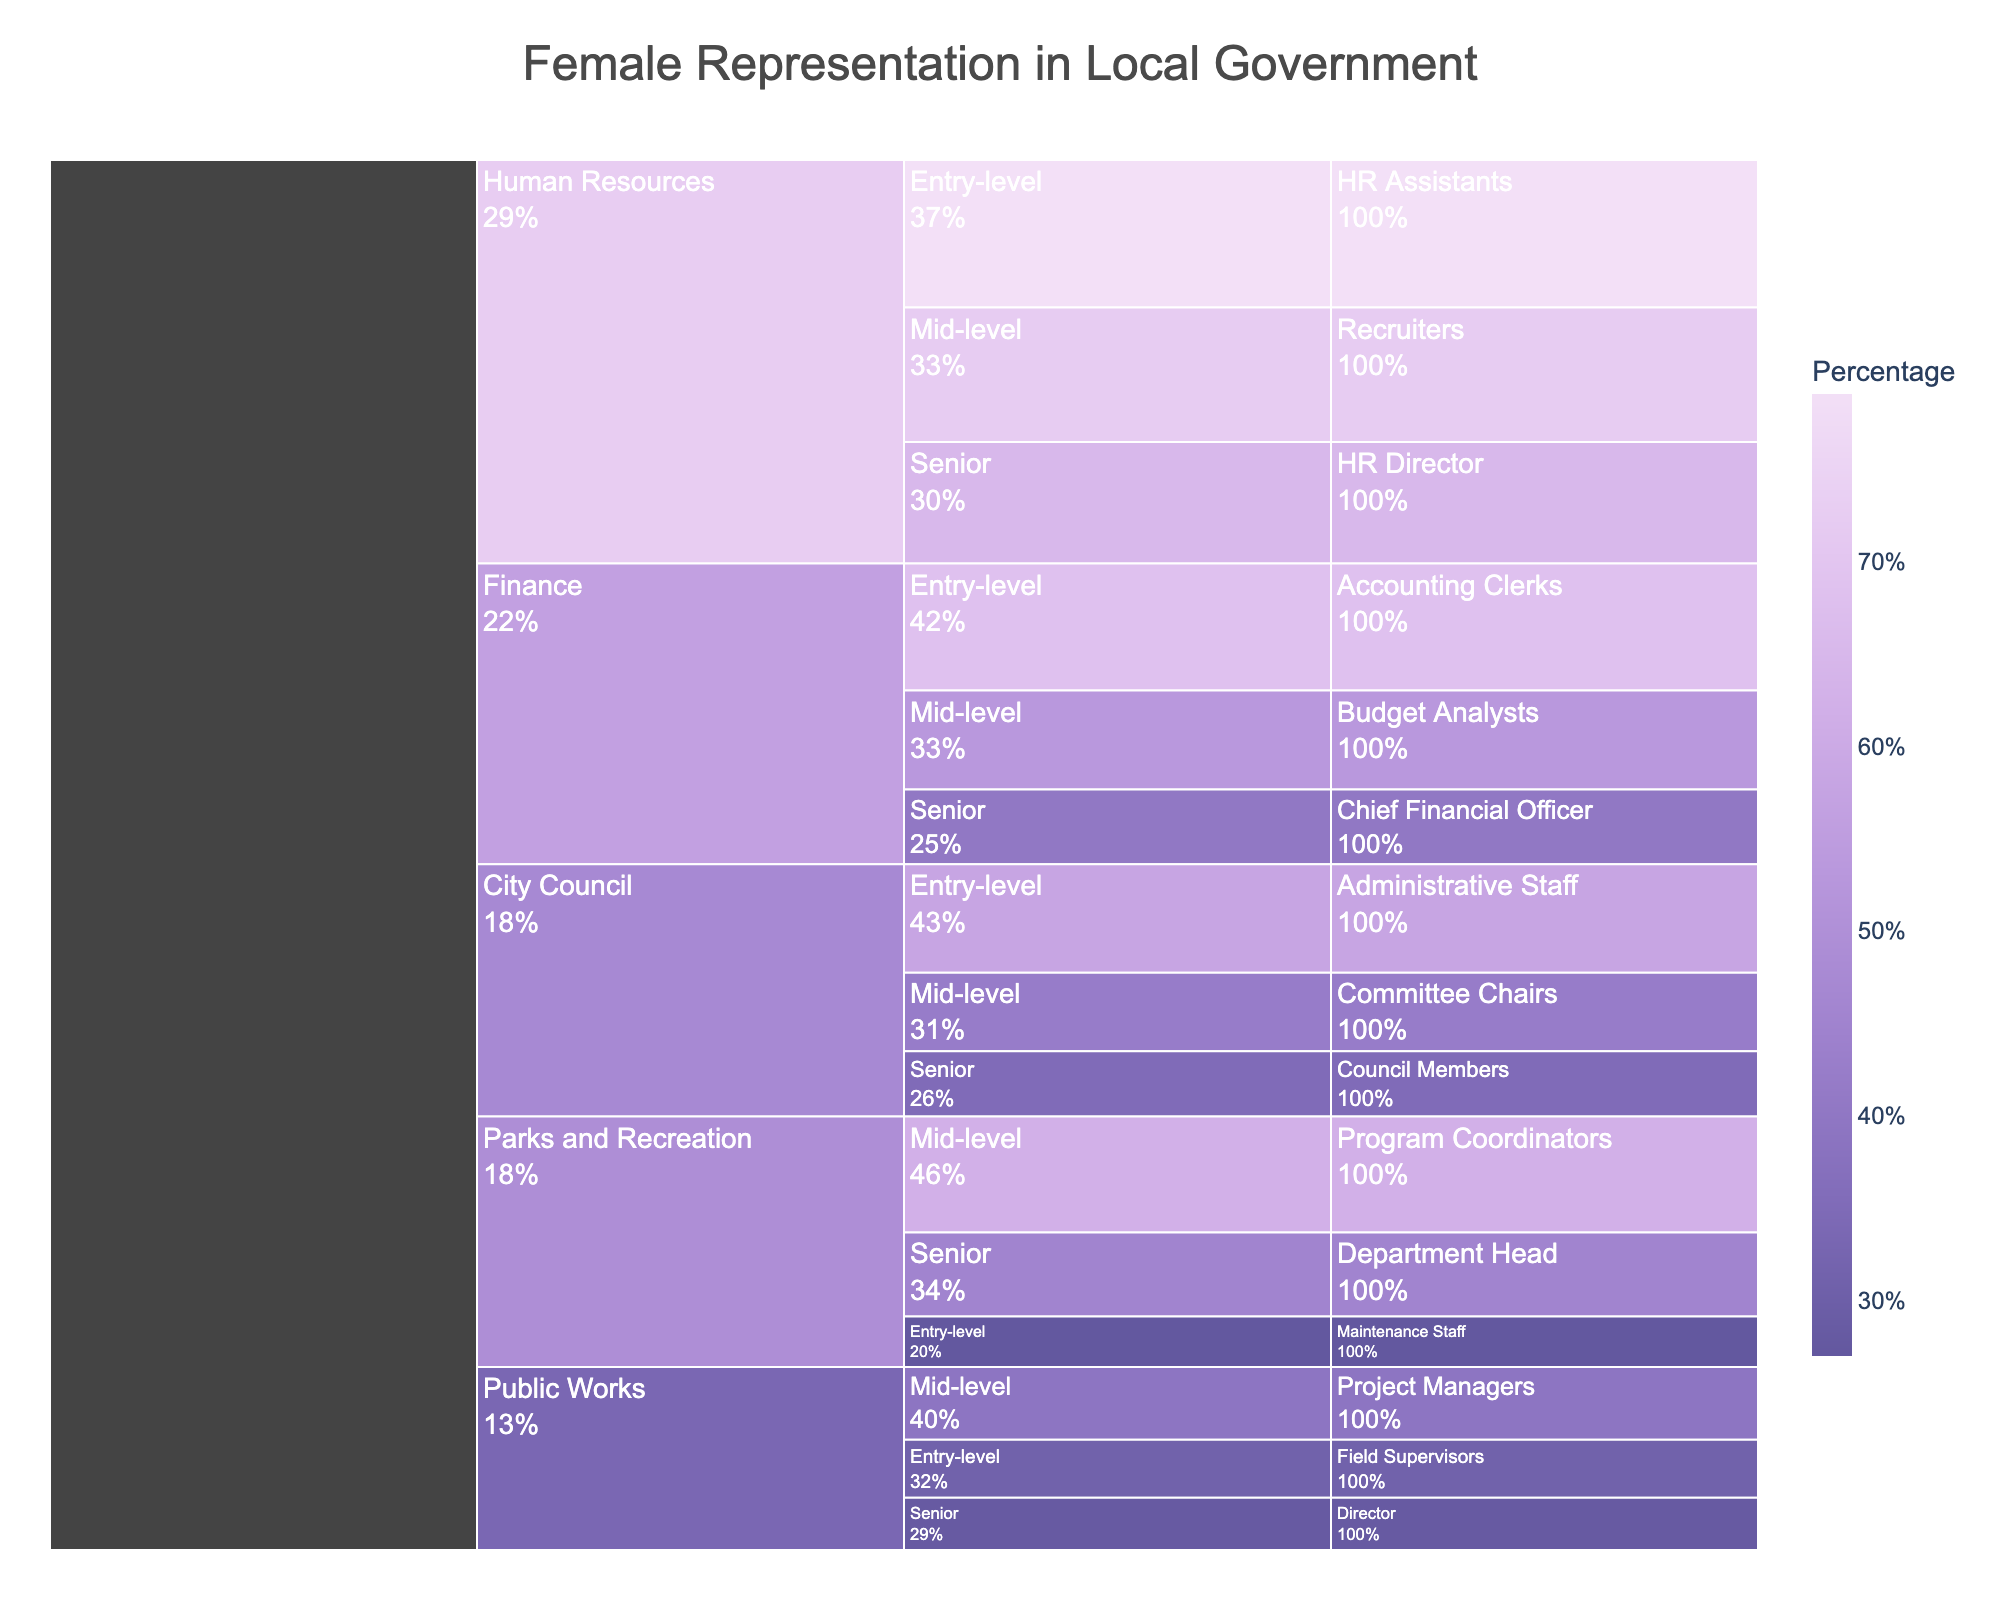What's the percentage of female administrative staff in the City Council? Look for the City Council branch of the chart, then trace to the Administrative Staff under Entry-level positions. The percentage is displayed.
Answer: 58% How does female representation in mid-level finance positions compare to mid-level public works positions? Locate the mid-level positions under Finance (Budget Analysts) and Public Works (Project Managers). Compare their percentages.
Answer: 53% (Finance) vs. 39% (Public Works) What is the average percentage of female representation in senior positions across all departments? Extract the percentages of senior positions: Council Members (35%), Director (28%), Department Head (45%), Chief Financial Officer (40%), HR Director (65%). Sum them and divide by the number of departments. (35 + 28 + 45 + 40 + 65) / 5 = 42.6.
Answer: 42.6% Which department has the highest percentage of female representation at entry-level positions? Check the percentages for entry-level positions across City Council (Administrative Staff - 58%), Public Works (Field Supervisors - 31%), Parks and Recreation (Maintenance Staff - 27%), Finance (Accounting Clerks - 68%), and Human Resources (HR Assistants - 79%).
Answer: Human Resources (79%) Is female representation higher in Program Coordinators of Parks and Recreation or Recruiters in Human Resources? Find the percentages for Parks and Recreation (Program Coordinators - 62%) and Human Resources (Recruiters - 72%) and compare.
Answer: Recruiters in Human Resources (72%) What is the female representation percentage for the City Council's Committee Chairs? Locate the City Council segment, find Committee Chairs under Mid-level positions. The percentage is displayed.
Answer: 42% Which department shows the lowest female representation at any level, and what is the percentage? Check all levels and departments: Public Works, Field Supervisors, Entry-level. This representation is 27%.
Answer: Parks and Recreation (27%) What is the total percentage of female representation at the mid-level positions across all departments? Sum the percentages of mid-level positions: Committee Chairs (42%), Project Managers (39%), Program Coordinators (62%), Budget Analysts (53%), Recruiters (72%).
Answer: 268% In which department and position is the female representation percentage exactly 65%? Locate the percentage of 65% in the chart and identify the associated department and position. HR Director in Human Resources.
Answer: HR Director in Human Resources Which department has the most balanced female representation across all levels? Analyze the percentages within each department to determine variability: City Council (35%, 42%, 58%), Public Works (28%, 39%, 31%), Parks and Recreation (45%, 62%, 27%), Finance (40%, 53%, 68%), Human Resources (65%, 72%, 79%).
Answer: City Council (variability: 35-58%) 